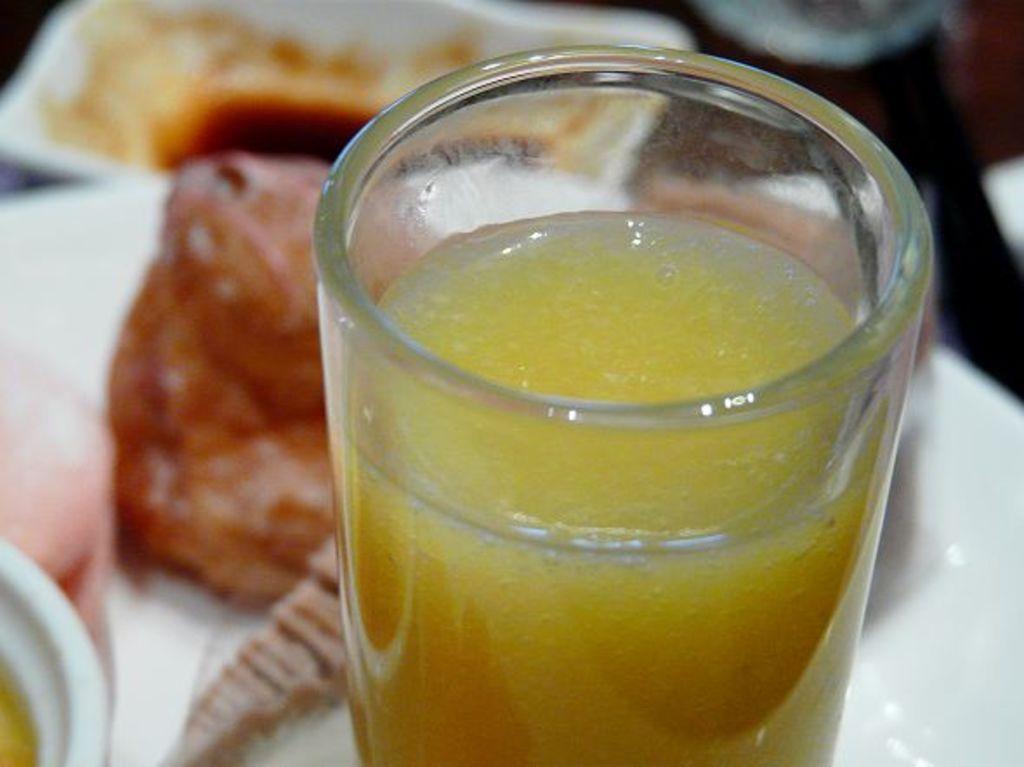Describe this image in one or two sentences. In this image in the front there is a glass with a juice inside it and in the background there is food 